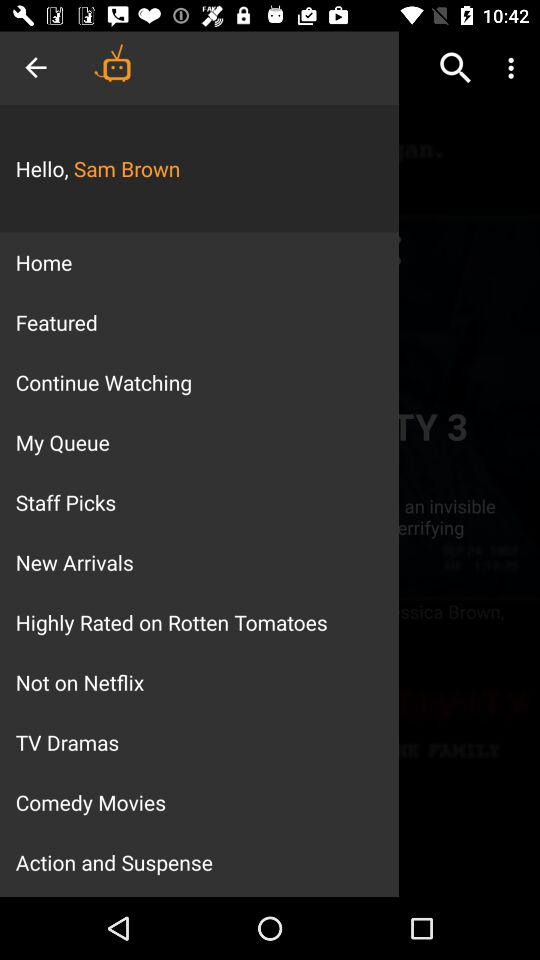What is the user name? The user name is Sam Brown. 